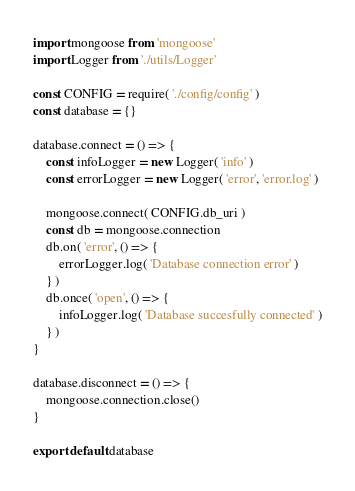<code> <loc_0><loc_0><loc_500><loc_500><_JavaScript_>import mongoose from 'mongoose'
import Logger from './utils/Logger'

const CONFIG = require( './config/config' )
const database = {}

database.connect = () => {
    const infoLogger = new Logger( 'info' )
    const errorLogger = new Logger( 'error', 'error.log' )

    mongoose.connect( CONFIG.db_uri )
    const db = mongoose.connection
    db.on( 'error', () => {
        errorLogger.log( 'Database connection error' )
    } )
    db.once( 'open', () => {
        infoLogger.log( 'Database succesfully connected' )
    } )
}

database.disconnect = () => {
    mongoose.connection.close()
}

export default database
</code> 